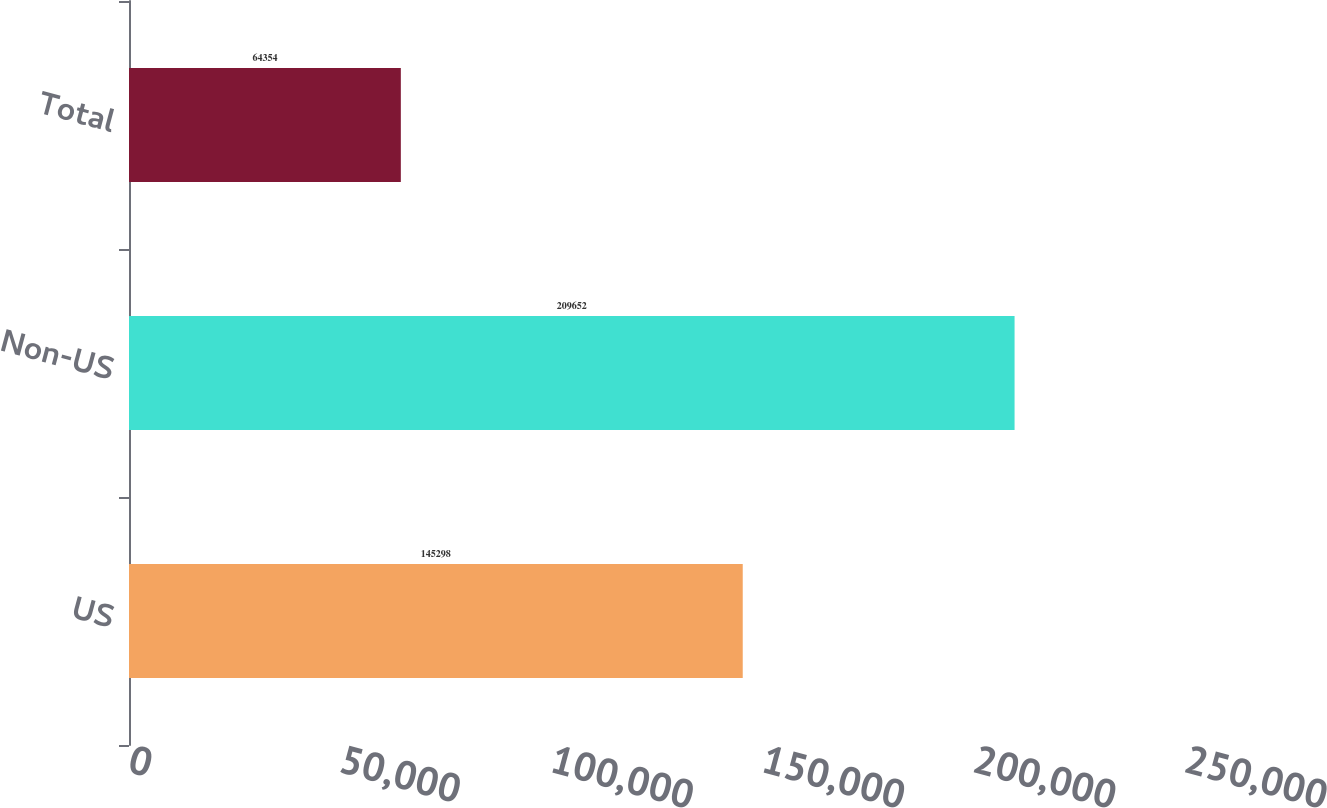Convert chart to OTSL. <chart><loc_0><loc_0><loc_500><loc_500><bar_chart><fcel>US<fcel>Non-US<fcel>Total<nl><fcel>145298<fcel>209652<fcel>64354<nl></chart> 